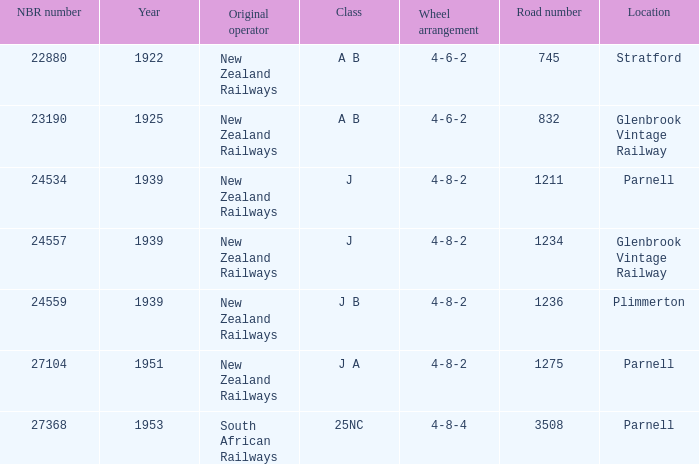What is the top nbr number related to the j class and the road number of 1211? 24534.0. 